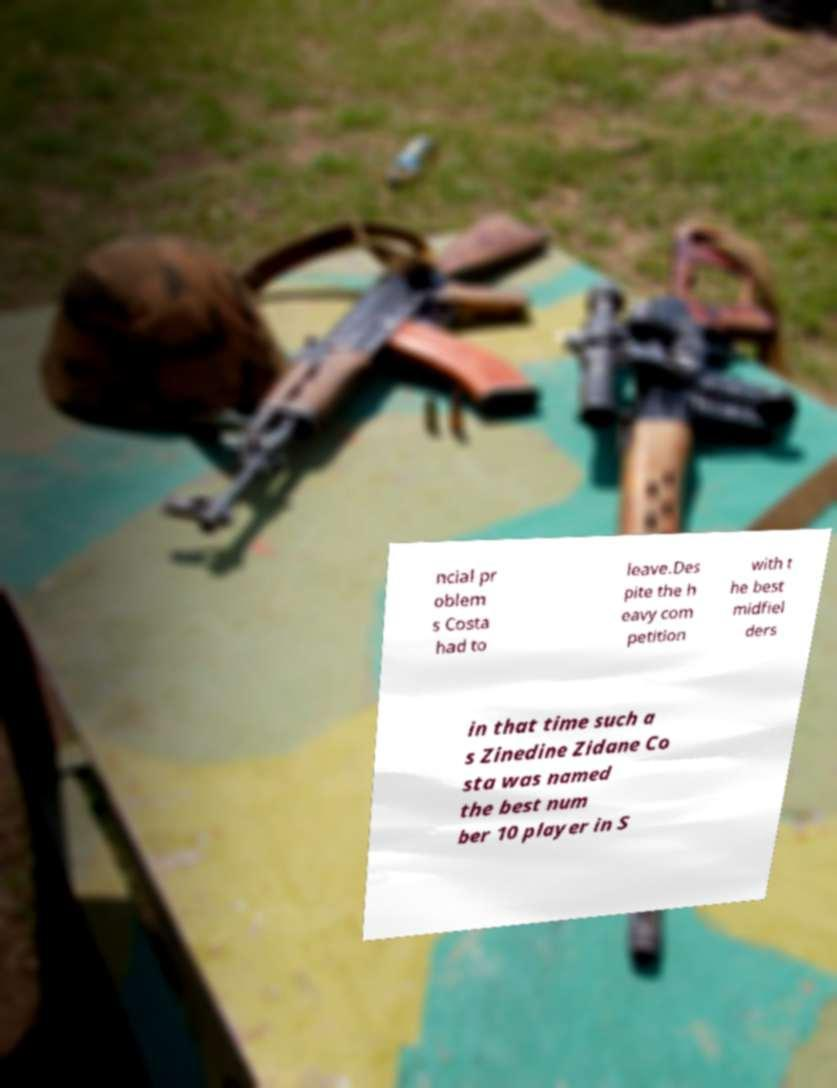Please read and relay the text visible in this image. What does it say? ncial pr oblem s Costa had to leave.Des pite the h eavy com petition with t he best midfiel ders in that time such a s Zinedine Zidane Co sta was named the best num ber 10 player in S 